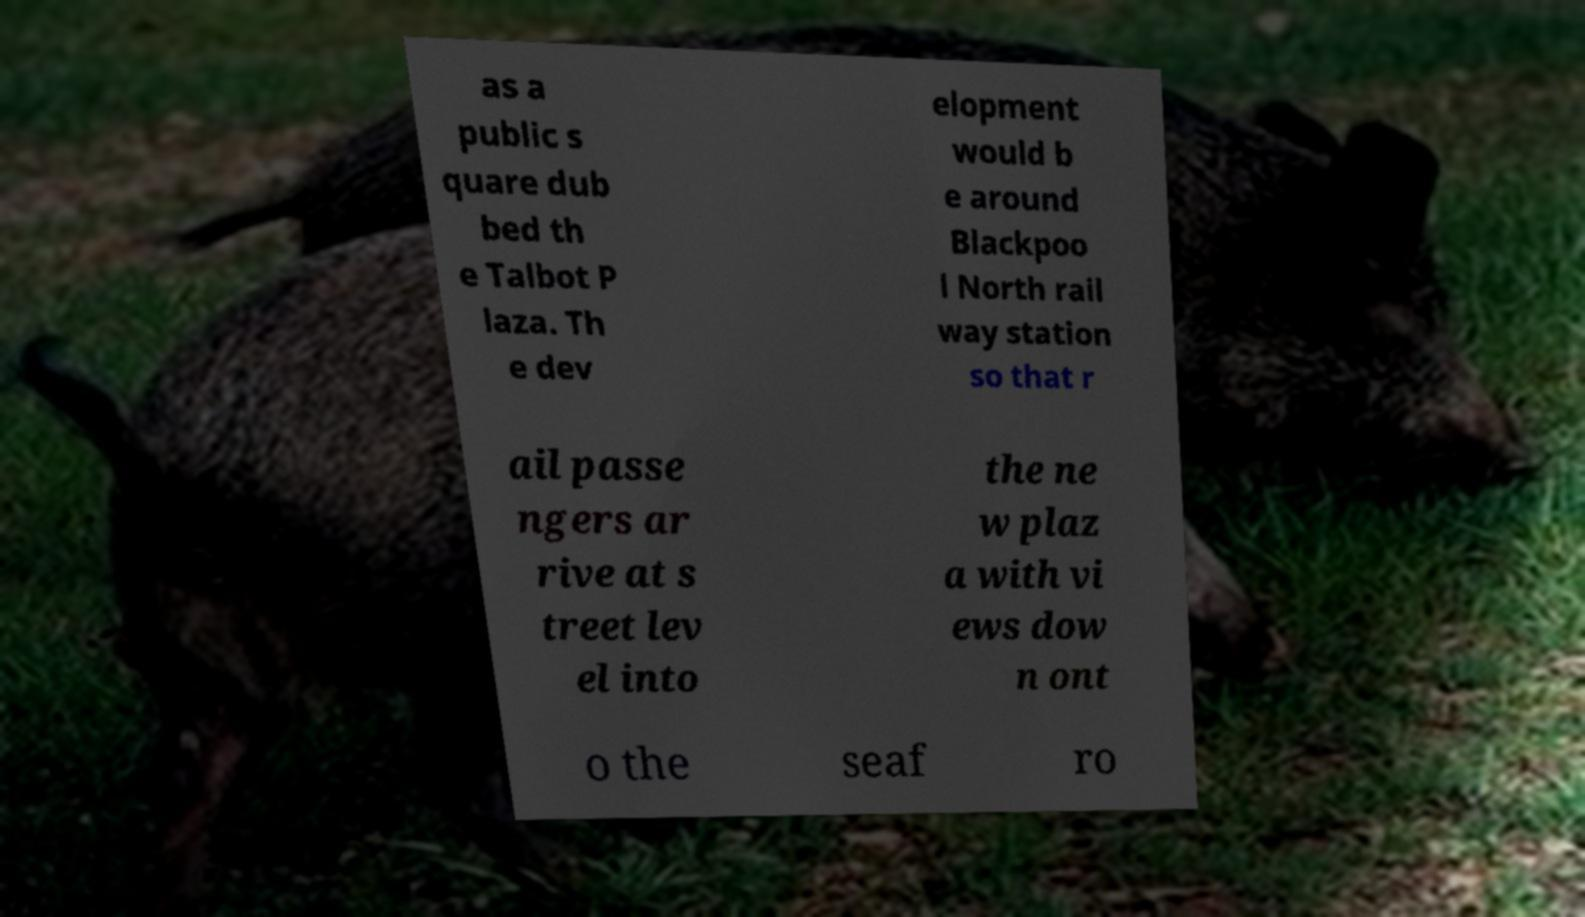Please read and relay the text visible in this image. What does it say? as a public s quare dub bed th e Talbot P laza. Th e dev elopment would b e around Blackpoo l North rail way station so that r ail passe ngers ar rive at s treet lev el into the ne w plaz a with vi ews dow n ont o the seaf ro 